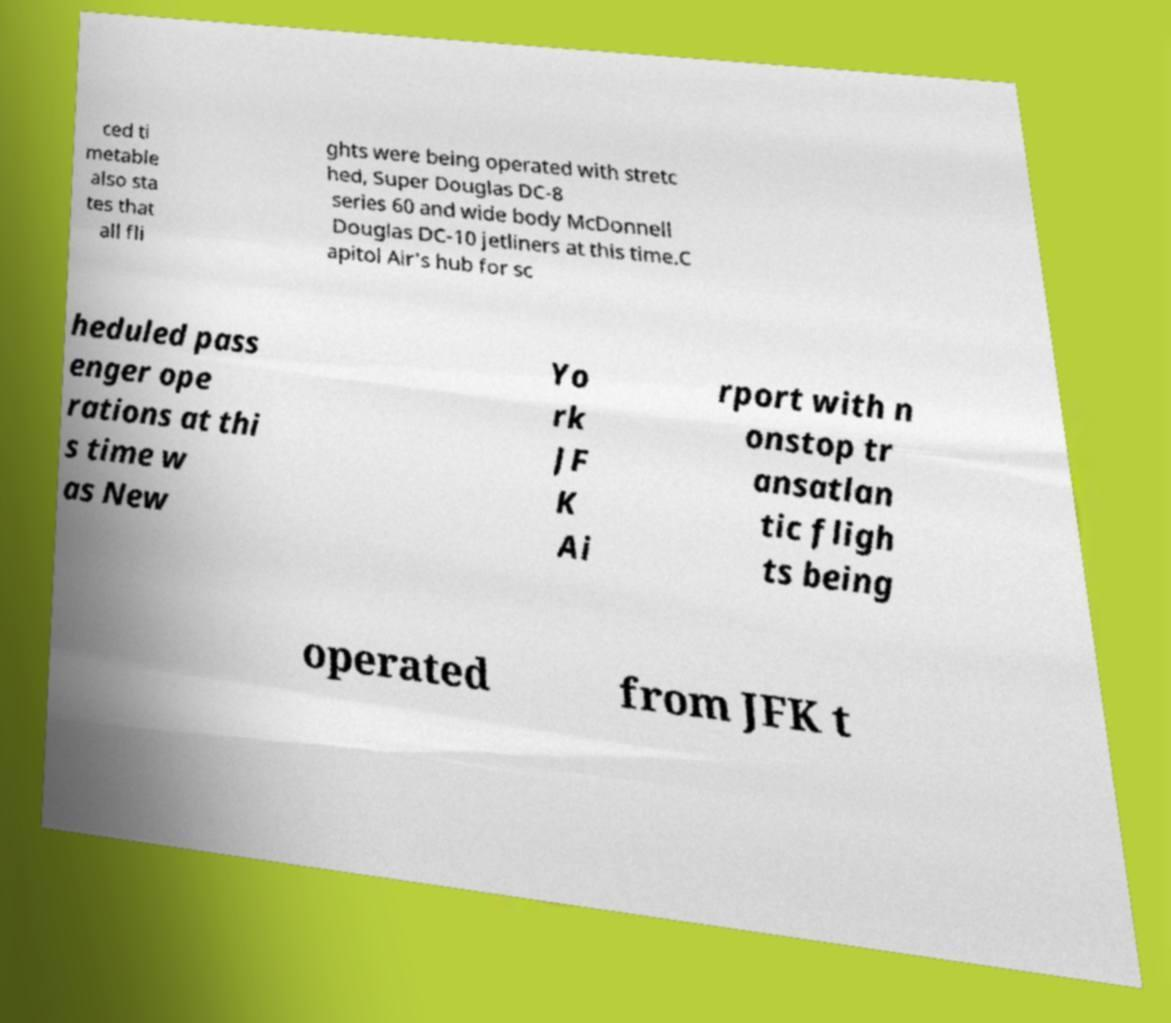Please identify and transcribe the text found in this image. ced ti metable also sta tes that all fli ghts were being operated with stretc hed, Super Douglas DC-8 series 60 and wide body McDonnell Douglas DC-10 jetliners at this time.C apitol Air's hub for sc heduled pass enger ope rations at thi s time w as New Yo rk JF K Ai rport with n onstop tr ansatlan tic fligh ts being operated from JFK t 